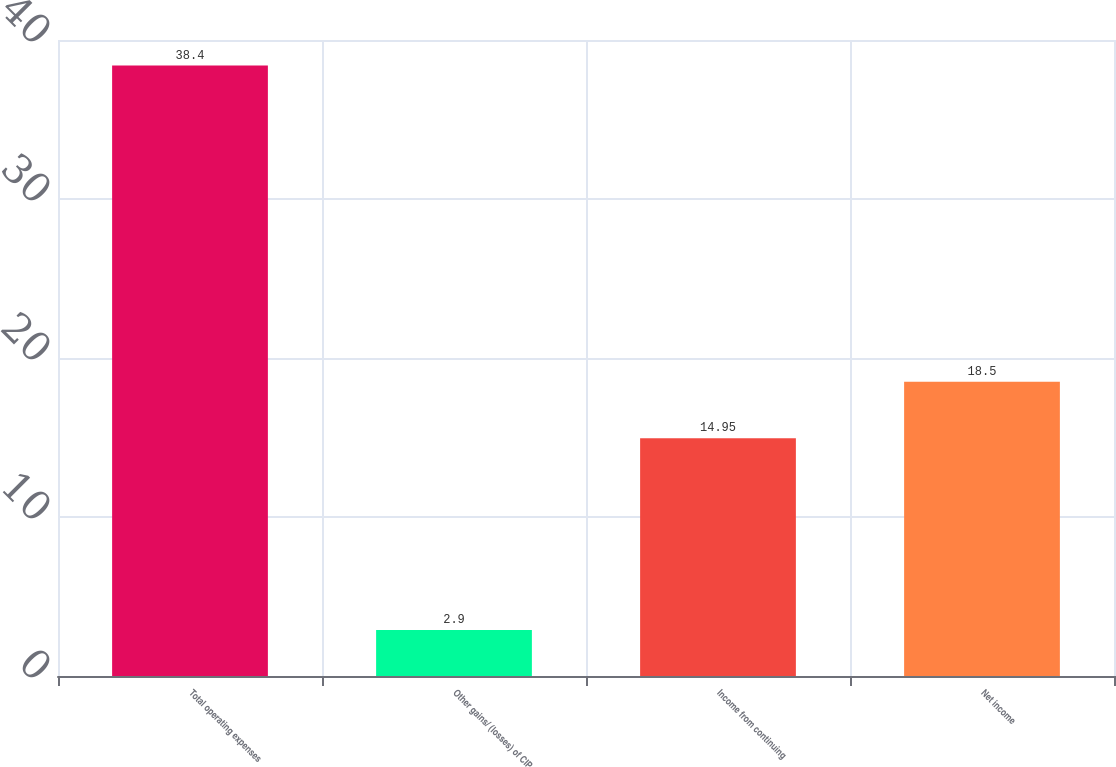<chart> <loc_0><loc_0><loc_500><loc_500><bar_chart><fcel>Total operating expenses<fcel>Other gains/ (losses) of CIP<fcel>Income from continuing<fcel>Net income<nl><fcel>38.4<fcel>2.9<fcel>14.95<fcel>18.5<nl></chart> 